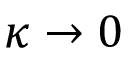Convert formula to latex. <formula><loc_0><loc_0><loc_500><loc_500>\kappa \to 0</formula> 